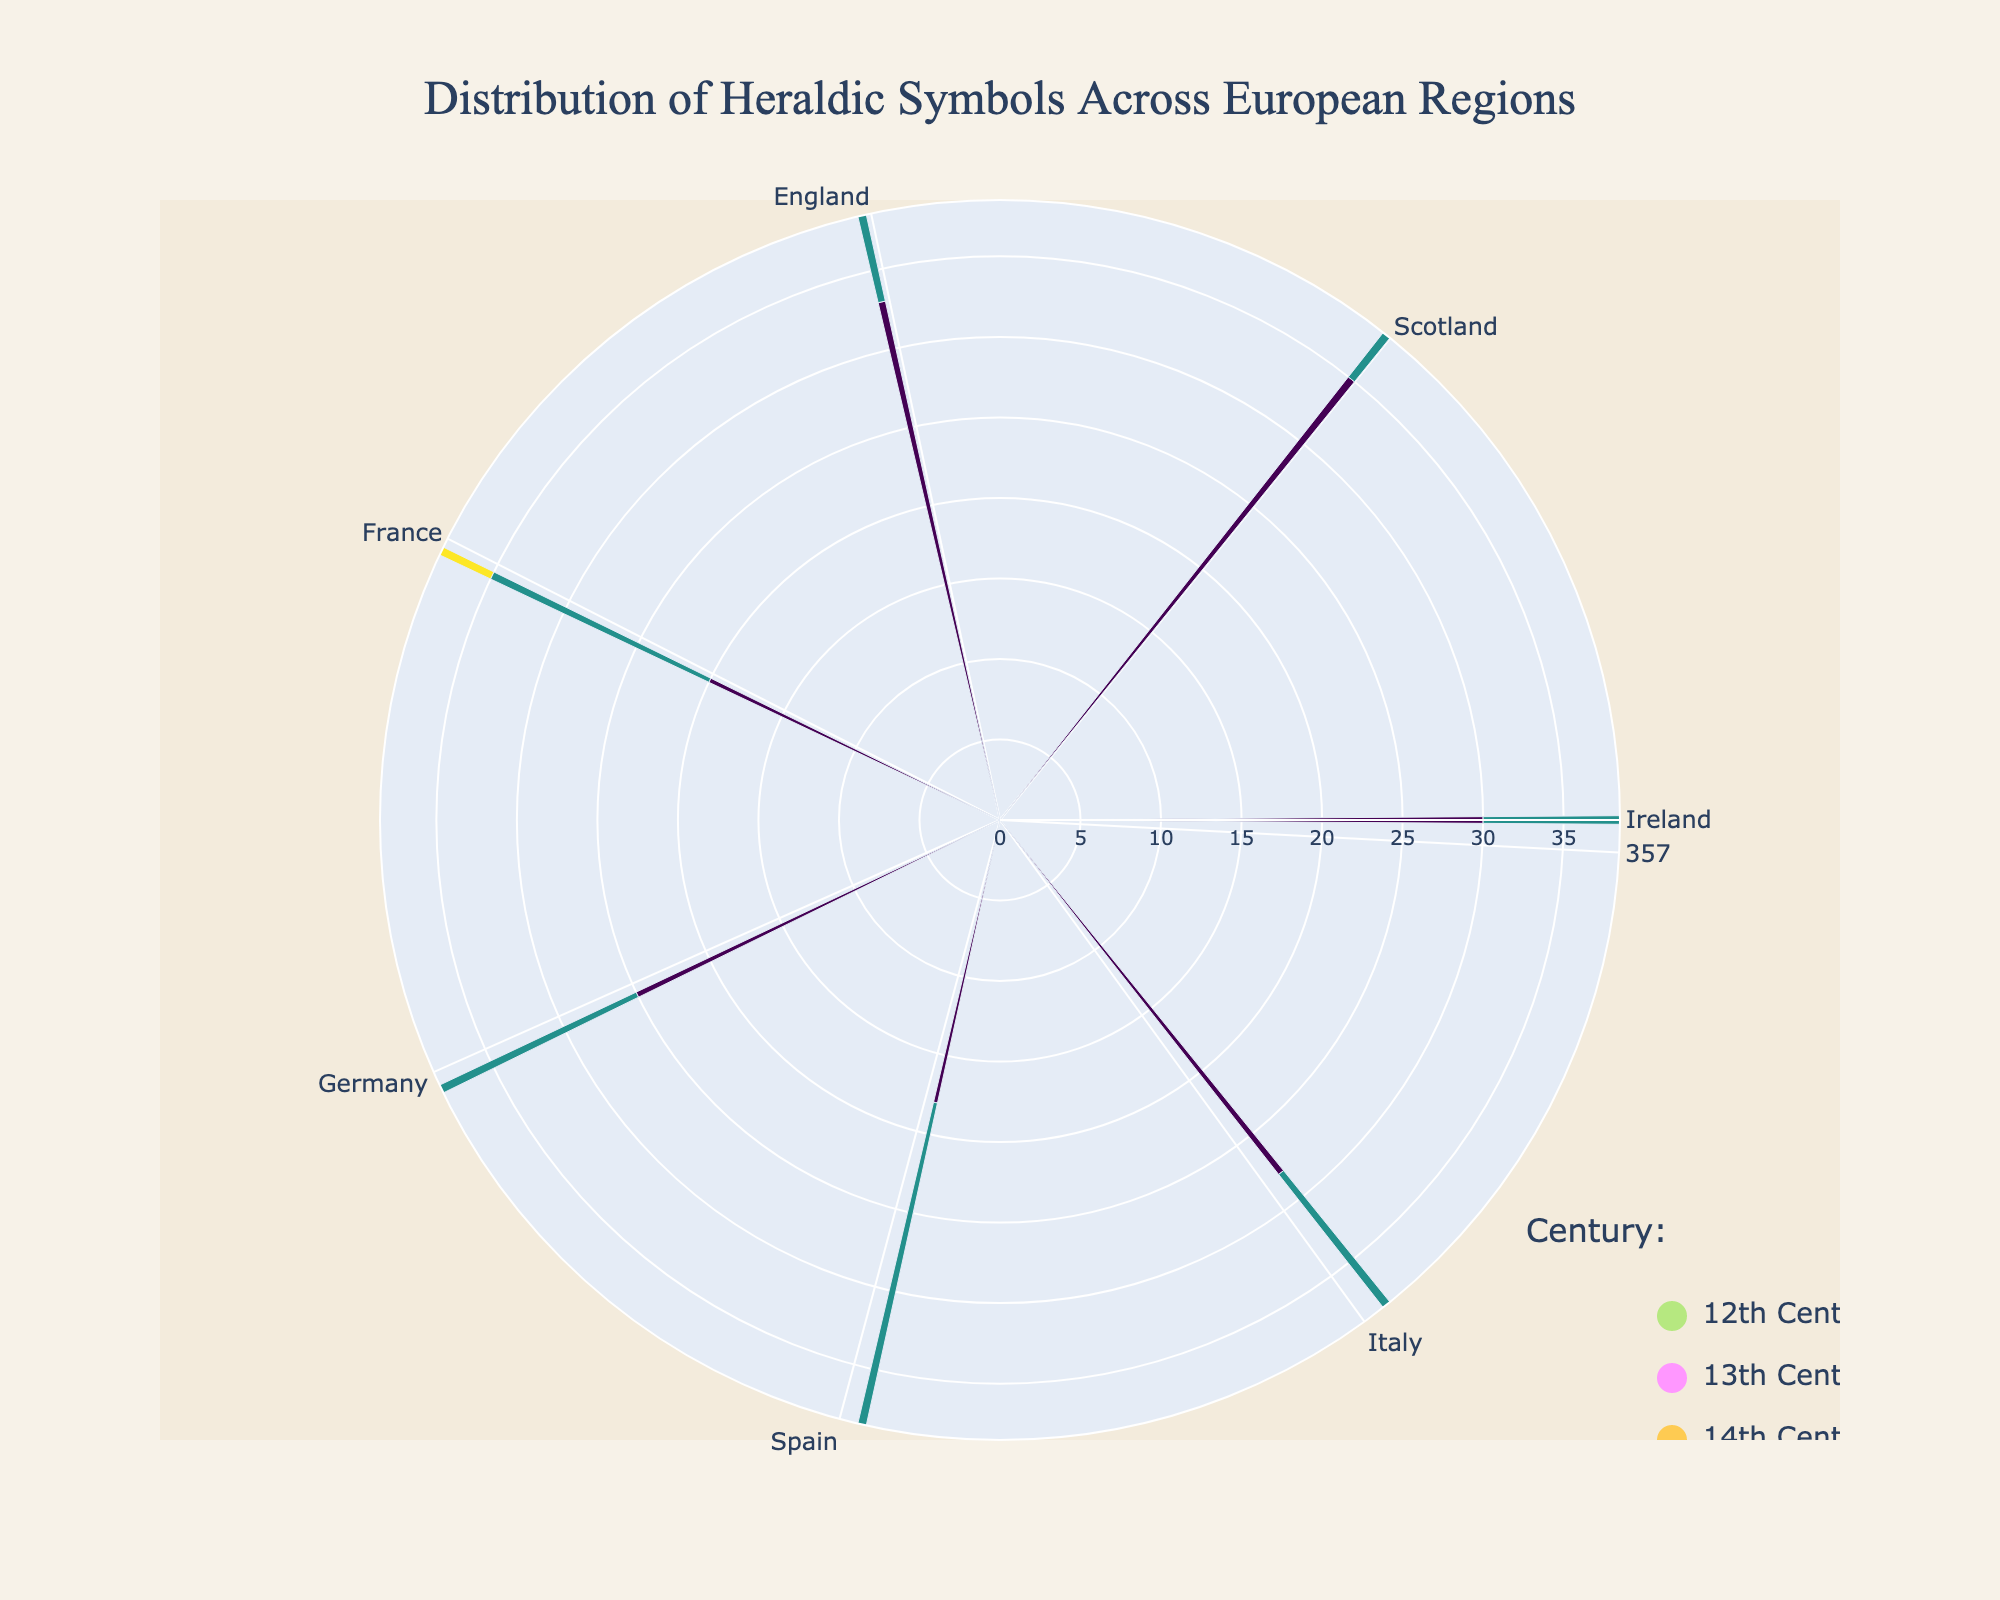What is the title of the chart? The title is usually displayed at the top of the chart. Here, it reads "Distribution of Heraldic Symbols Across European Regions."
Answer: Distribution of Heraldic Symbols Across European Regions Which century had the highest frequency of heraldic symbols in Ireland? To answer this, locate the sections labeled Ireland on the polar chart and compare the frequencies of each century. The 12th century has the largest bar with a frequency of 20.
Answer: 12th Century What symbol was most frequent in France during the 12th century? Look for the bar segment specific to France and the 12th century. The longest bar will indicate the most frequent symbol, which is the Fleur-de-Lis with a frequency of 35.
Answer: Fleur-de-Lis How does the frequency of the Lion Rampant in Scotland in the 13th century compare to the same symbol in France in the 14th century? Locate the Lion Rampant bar segments for Scotland in the 13th century and France in the 14th century. In Scotland, it's 25, whereas in France, it's 18. Thus, the symbol is more frequent in Scotland during the 13th century.
Answer: More frequent in Scotland during the 13th century Which region in the 12th century has the highest number of heraldic symbols? Identify the 12th-century segments for each region. France has the tallest bar with a frequency of 35 for the Fleur-de-Lis.
Answer: France Which symbol was consistently used across multiple centuries in Italy? Examine Italy's sections across the centuries to find any recurring symbols. The Fleur-de-Lis appears again in the 14th century, but no earlier. Therefore, there are no consistent symbols across multiple centuries.
Answer: None What is the total frequency of heraldic symbols in England across all centuries? Sum the frequencies of symbols in England for all centuries: 30 (Lion Passant) + 27 (St George’s Cross) + 22 (Fleur-de-Lis). The total frequency is 79.
Answer: 79 Is there a region where the heraldic symbols' frequency decreases over centuries? Compare the frequencies for each symbol across the three centuries for every region. In Ireland, the frequencies decrease: 12th (20), 13th (15), and 14th (10).
Answer: Ireland How many regions display a symbol related to animals in the 12th century, and which regions are they? Count the 12th-century bar segments with animal-related symbols. Scotland (Thistle is plant, not animal), England (Lion Passant), Germany (Black Eagle), Spain (Castle is not animal), Italy (Imperial Eagle). There are two regions: England and Germany.
Answer: Two regions, England and Germany 